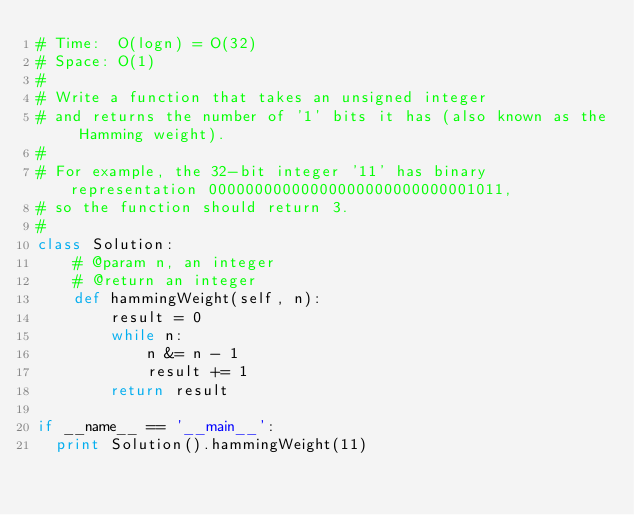<code> <loc_0><loc_0><loc_500><loc_500><_Python_># Time:  O(logn) = O(32)
# Space: O(1)
#
# Write a function that takes an unsigned integer 
# and returns the number of '1' bits it has (also known as the Hamming weight).
# 
# For example, the 32-bit integer '11' has binary representation 00000000000000000000000000001011, 
# so the function should return 3.
#
class Solution:
    # @param n, an integer
    # @return an integer
    def hammingWeight(self, n):
        result = 0
        while n:
            n &= n - 1
            result += 1
        return result

if __name__ == '__main__':
  print Solution().hammingWeight(11)
</code> 